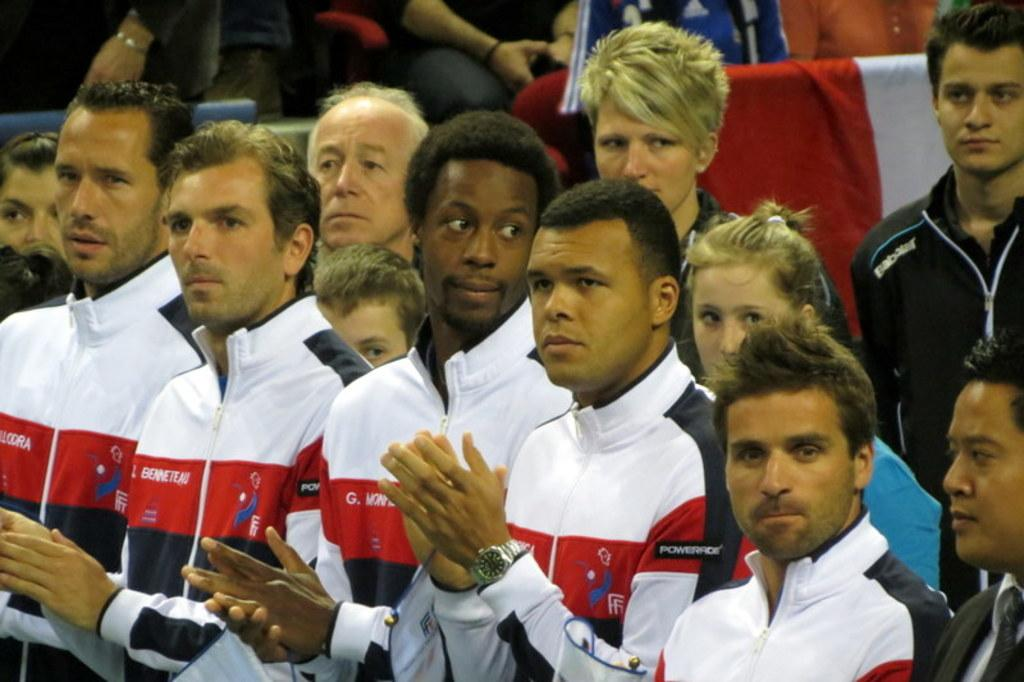Who is present in the image? There are people in the image. What are the people wearing? The people are wearing clothes. What are the people doing in the image? Some people are clapping. Can you identify any accessories in the image? Yes, there is a wrist watch visible in the image. What type of wine is being served at the event in the image? There is no mention of wine or an event in the image; it simply shows people clapping and wearing clothes. 